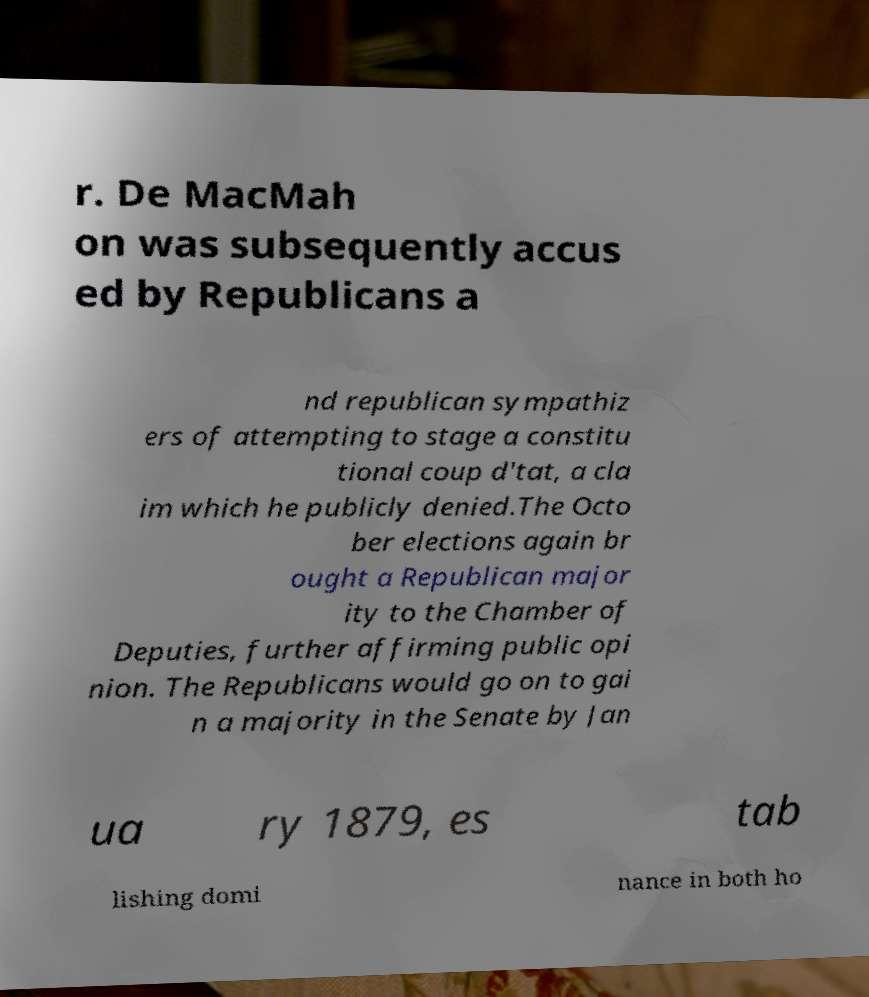Could you assist in decoding the text presented in this image and type it out clearly? r. De MacMah on was subsequently accus ed by Republicans a nd republican sympathiz ers of attempting to stage a constitu tional coup d'tat, a cla im which he publicly denied.The Octo ber elections again br ought a Republican major ity to the Chamber of Deputies, further affirming public opi nion. The Republicans would go on to gai n a majority in the Senate by Jan ua ry 1879, es tab lishing domi nance in both ho 